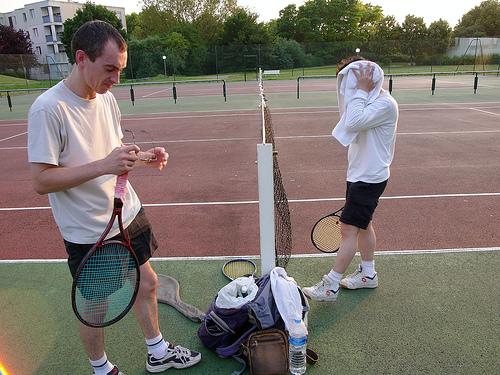Was this an exhausting match?
Give a very brief answer. Yes. What game were they playing?
Quick response, please. Tennis. What is the man on the left about to put on?
Answer briefly. Glasses. 